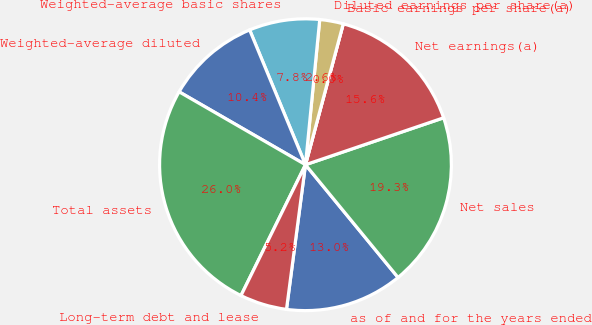<chart> <loc_0><loc_0><loc_500><loc_500><pie_chart><fcel>as of and for the years ended<fcel>Net sales<fcel>Net earnings(a)<fcel>Basic earnings per share(a)<fcel>Diluted earnings per share(a)<fcel>Weighted-average basic shares<fcel>Weighted-average diluted<fcel>Total assets<fcel>Long-term debt and lease<nl><fcel>13.02%<fcel>19.27%<fcel>15.62%<fcel>0.0%<fcel>2.61%<fcel>7.81%<fcel>10.42%<fcel>26.04%<fcel>5.21%<nl></chart> 